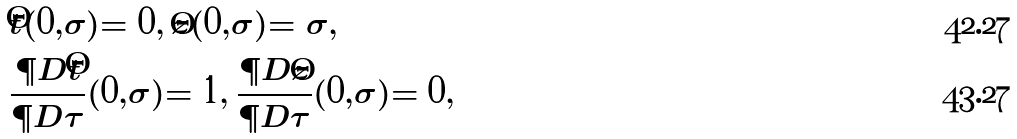<formula> <loc_0><loc_0><loc_500><loc_500>& \hat { t } ( 0 , \sigma ) = 0 , \, \hat { z } ( 0 , \sigma ) = \sigma , \\ & \frac { \P D \hat { t } } { \P D \tau } ( 0 , \sigma ) = 1 , \, \frac { \P D \hat { z } } { \P D \tau } ( 0 , \sigma ) = 0 ,</formula> 